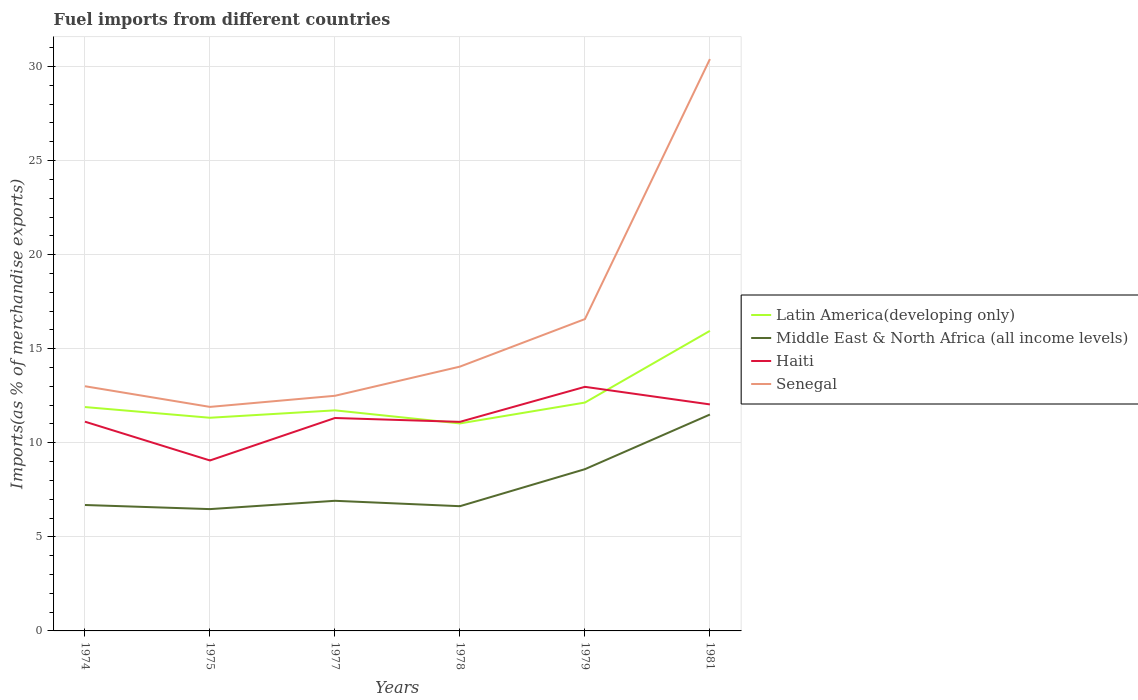Does the line corresponding to Middle East & North Africa (all income levels) intersect with the line corresponding to Senegal?
Make the answer very short. No. Is the number of lines equal to the number of legend labels?
Your response must be concise. Yes. Across all years, what is the maximum percentage of imports to different countries in Latin America(developing only)?
Offer a terse response. 11.03. In which year was the percentage of imports to different countries in Latin America(developing only) maximum?
Offer a terse response. 1978. What is the total percentage of imports to different countries in Senegal in the graph?
Offer a very short reply. -0.59. What is the difference between the highest and the second highest percentage of imports to different countries in Senegal?
Offer a very short reply. 18.49. What is the difference between the highest and the lowest percentage of imports to different countries in Middle East & North Africa (all income levels)?
Offer a very short reply. 2. How many lines are there?
Make the answer very short. 4. How many years are there in the graph?
Your answer should be very brief. 6. Are the values on the major ticks of Y-axis written in scientific E-notation?
Give a very brief answer. No. Does the graph contain any zero values?
Your answer should be very brief. No. Does the graph contain grids?
Your answer should be compact. Yes. Where does the legend appear in the graph?
Offer a terse response. Center right. How many legend labels are there?
Your response must be concise. 4. How are the legend labels stacked?
Give a very brief answer. Vertical. What is the title of the graph?
Provide a succinct answer. Fuel imports from different countries. Does "High income: OECD" appear as one of the legend labels in the graph?
Provide a succinct answer. No. What is the label or title of the X-axis?
Provide a short and direct response. Years. What is the label or title of the Y-axis?
Ensure brevity in your answer.  Imports(as % of merchandise exports). What is the Imports(as % of merchandise exports) of Latin America(developing only) in 1974?
Your response must be concise. 11.9. What is the Imports(as % of merchandise exports) in Middle East & North Africa (all income levels) in 1974?
Ensure brevity in your answer.  6.69. What is the Imports(as % of merchandise exports) of Haiti in 1974?
Your answer should be compact. 11.12. What is the Imports(as % of merchandise exports) of Senegal in 1974?
Give a very brief answer. 13.01. What is the Imports(as % of merchandise exports) of Latin America(developing only) in 1975?
Keep it short and to the point. 11.33. What is the Imports(as % of merchandise exports) of Middle East & North Africa (all income levels) in 1975?
Ensure brevity in your answer.  6.47. What is the Imports(as % of merchandise exports) in Haiti in 1975?
Your response must be concise. 9.06. What is the Imports(as % of merchandise exports) of Senegal in 1975?
Offer a terse response. 11.91. What is the Imports(as % of merchandise exports) in Latin America(developing only) in 1977?
Give a very brief answer. 11.72. What is the Imports(as % of merchandise exports) of Middle East & North Africa (all income levels) in 1977?
Offer a very short reply. 6.92. What is the Imports(as % of merchandise exports) of Haiti in 1977?
Give a very brief answer. 11.32. What is the Imports(as % of merchandise exports) of Senegal in 1977?
Provide a short and direct response. 12.5. What is the Imports(as % of merchandise exports) in Latin America(developing only) in 1978?
Make the answer very short. 11.03. What is the Imports(as % of merchandise exports) in Middle East & North Africa (all income levels) in 1978?
Your answer should be very brief. 6.63. What is the Imports(as % of merchandise exports) in Haiti in 1978?
Your response must be concise. 11.11. What is the Imports(as % of merchandise exports) of Senegal in 1978?
Your answer should be very brief. 14.05. What is the Imports(as % of merchandise exports) of Latin America(developing only) in 1979?
Offer a terse response. 12.14. What is the Imports(as % of merchandise exports) in Middle East & North Africa (all income levels) in 1979?
Make the answer very short. 8.6. What is the Imports(as % of merchandise exports) of Haiti in 1979?
Provide a short and direct response. 12.97. What is the Imports(as % of merchandise exports) in Senegal in 1979?
Your answer should be compact. 16.58. What is the Imports(as % of merchandise exports) in Latin America(developing only) in 1981?
Provide a short and direct response. 15.95. What is the Imports(as % of merchandise exports) in Middle East & North Africa (all income levels) in 1981?
Provide a succinct answer. 11.5. What is the Imports(as % of merchandise exports) of Haiti in 1981?
Your answer should be compact. 12.04. What is the Imports(as % of merchandise exports) of Senegal in 1981?
Give a very brief answer. 30.4. Across all years, what is the maximum Imports(as % of merchandise exports) of Latin America(developing only)?
Provide a short and direct response. 15.95. Across all years, what is the maximum Imports(as % of merchandise exports) in Middle East & North Africa (all income levels)?
Provide a short and direct response. 11.5. Across all years, what is the maximum Imports(as % of merchandise exports) of Haiti?
Make the answer very short. 12.97. Across all years, what is the maximum Imports(as % of merchandise exports) of Senegal?
Offer a terse response. 30.4. Across all years, what is the minimum Imports(as % of merchandise exports) in Latin America(developing only)?
Make the answer very short. 11.03. Across all years, what is the minimum Imports(as % of merchandise exports) of Middle East & North Africa (all income levels)?
Ensure brevity in your answer.  6.47. Across all years, what is the minimum Imports(as % of merchandise exports) in Haiti?
Provide a succinct answer. 9.06. Across all years, what is the minimum Imports(as % of merchandise exports) in Senegal?
Make the answer very short. 11.91. What is the total Imports(as % of merchandise exports) of Latin America(developing only) in the graph?
Your answer should be very brief. 74.07. What is the total Imports(as % of merchandise exports) of Middle East & North Africa (all income levels) in the graph?
Your response must be concise. 46.81. What is the total Imports(as % of merchandise exports) in Haiti in the graph?
Keep it short and to the point. 67.63. What is the total Imports(as % of merchandise exports) in Senegal in the graph?
Give a very brief answer. 98.43. What is the difference between the Imports(as % of merchandise exports) of Latin America(developing only) in 1974 and that in 1975?
Provide a short and direct response. 0.57. What is the difference between the Imports(as % of merchandise exports) of Middle East & North Africa (all income levels) in 1974 and that in 1975?
Offer a terse response. 0.22. What is the difference between the Imports(as % of merchandise exports) of Haiti in 1974 and that in 1975?
Offer a very short reply. 2.06. What is the difference between the Imports(as % of merchandise exports) in Senegal in 1974 and that in 1975?
Provide a succinct answer. 1.1. What is the difference between the Imports(as % of merchandise exports) in Latin America(developing only) in 1974 and that in 1977?
Your response must be concise. 0.18. What is the difference between the Imports(as % of merchandise exports) of Middle East & North Africa (all income levels) in 1974 and that in 1977?
Your answer should be very brief. -0.22. What is the difference between the Imports(as % of merchandise exports) of Haiti in 1974 and that in 1977?
Keep it short and to the point. -0.2. What is the difference between the Imports(as % of merchandise exports) in Senegal in 1974 and that in 1977?
Offer a terse response. 0.51. What is the difference between the Imports(as % of merchandise exports) of Latin America(developing only) in 1974 and that in 1978?
Provide a succinct answer. 0.87. What is the difference between the Imports(as % of merchandise exports) of Middle East & North Africa (all income levels) in 1974 and that in 1978?
Make the answer very short. 0.06. What is the difference between the Imports(as % of merchandise exports) of Haiti in 1974 and that in 1978?
Your answer should be very brief. 0.01. What is the difference between the Imports(as % of merchandise exports) in Senegal in 1974 and that in 1978?
Offer a very short reply. -1.04. What is the difference between the Imports(as % of merchandise exports) in Latin America(developing only) in 1974 and that in 1979?
Ensure brevity in your answer.  -0.24. What is the difference between the Imports(as % of merchandise exports) in Middle East & North Africa (all income levels) in 1974 and that in 1979?
Provide a short and direct response. -1.9. What is the difference between the Imports(as % of merchandise exports) in Haiti in 1974 and that in 1979?
Offer a very short reply. -1.85. What is the difference between the Imports(as % of merchandise exports) of Senegal in 1974 and that in 1979?
Provide a succinct answer. -3.57. What is the difference between the Imports(as % of merchandise exports) of Latin America(developing only) in 1974 and that in 1981?
Offer a terse response. -4.05. What is the difference between the Imports(as % of merchandise exports) of Middle East & North Africa (all income levels) in 1974 and that in 1981?
Ensure brevity in your answer.  -4.81. What is the difference between the Imports(as % of merchandise exports) of Haiti in 1974 and that in 1981?
Provide a succinct answer. -0.92. What is the difference between the Imports(as % of merchandise exports) of Senegal in 1974 and that in 1981?
Give a very brief answer. -17.39. What is the difference between the Imports(as % of merchandise exports) in Latin America(developing only) in 1975 and that in 1977?
Keep it short and to the point. -0.39. What is the difference between the Imports(as % of merchandise exports) of Middle East & North Africa (all income levels) in 1975 and that in 1977?
Offer a very short reply. -0.44. What is the difference between the Imports(as % of merchandise exports) in Haiti in 1975 and that in 1977?
Your response must be concise. -2.26. What is the difference between the Imports(as % of merchandise exports) in Senegal in 1975 and that in 1977?
Offer a terse response. -0.59. What is the difference between the Imports(as % of merchandise exports) in Latin America(developing only) in 1975 and that in 1978?
Offer a terse response. 0.3. What is the difference between the Imports(as % of merchandise exports) of Middle East & North Africa (all income levels) in 1975 and that in 1978?
Your answer should be very brief. -0.15. What is the difference between the Imports(as % of merchandise exports) of Haiti in 1975 and that in 1978?
Provide a succinct answer. -2.05. What is the difference between the Imports(as % of merchandise exports) of Senegal in 1975 and that in 1978?
Your response must be concise. -2.14. What is the difference between the Imports(as % of merchandise exports) in Latin America(developing only) in 1975 and that in 1979?
Offer a very short reply. -0.81. What is the difference between the Imports(as % of merchandise exports) in Middle East & North Africa (all income levels) in 1975 and that in 1979?
Your answer should be very brief. -2.12. What is the difference between the Imports(as % of merchandise exports) of Haiti in 1975 and that in 1979?
Provide a short and direct response. -3.91. What is the difference between the Imports(as % of merchandise exports) of Senegal in 1975 and that in 1979?
Provide a short and direct response. -4.67. What is the difference between the Imports(as % of merchandise exports) of Latin America(developing only) in 1975 and that in 1981?
Make the answer very short. -4.62. What is the difference between the Imports(as % of merchandise exports) of Middle East & North Africa (all income levels) in 1975 and that in 1981?
Offer a terse response. -5.03. What is the difference between the Imports(as % of merchandise exports) in Haiti in 1975 and that in 1981?
Offer a terse response. -2.98. What is the difference between the Imports(as % of merchandise exports) of Senegal in 1975 and that in 1981?
Your answer should be compact. -18.49. What is the difference between the Imports(as % of merchandise exports) of Latin America(developing only) in 1977 and that in 1978?
Keep it short and to the point. 0.69. What is the difference between the Imports(as % of merchandise exports) in Middle East & North Africa (all income levels) in 1977 and that in 1978?
Provide a succinct answer. 0.29. What is the difference between the Imports(as % of merchandise exports) in Haiti in 1977 and that in 1978?
Your response must be concise. 0.2. What is the difference between the Imports(as % of merchandise exports) in Senegal in 1977 and that in 1978?
Offer a very short reply. -1.55. What is the difference between the Imports(as % of merchandise exports) in Latin America(developing only) in 1977 and that in 1979?
Your response must be concise. -0.41. What is the difference between the Imports(as % of merchandise exports) in Middle East & North Africa (all income levels) in 1977 and that in 1979?
Your answer should be compact. -1.68. What is the difference between the Imports(as % of merchandise exports) of Haiti in 1977 and that in 1979?
Your response must be concise. -1.66. What is the difference between the Imports(as % of merchandise exports) in Senegal in 1977 and that in 1979?
Give a very brief answer. -4.08. What is the difference between the Imports(as % of merchandise exports) of Latin America(developing only) in 1977 and that in 1981?
Make the answer very short. -4.23. What is the difference between the Imports(as % of merchandise exports) in Middle East & North Africa (all income levels) in 1977 and that in 1981?
Your answer should be very brief. -4.59. What is the difference between the Imports(as % of merchandise exports) in Haiti in 1977 and that in 1981?
Provide a short and direct response. -0.72. What is the difference between the Imports(as % of merchandise exports) of Senegal in 1977 and that in 1981?
Offer a terse response. -17.9. What is the difference between the Imports(as % of merchandise exports) in Latin America(developing only) in 1978 and that in 1979?
Keep it short and to the point. -1.11. What is the difference between the Imports(as % of merchandise exports) in Middle East & North Africa (all income levels) in 1978 and that in 1979?
Your answer should be compact. -1.97. What is the difference between the Imports(as % of merchandise exports) in Haiti in 1978 and that in 1979?
Provide a short and direct response. -1.86. What is the difference between the Imports(as % of merchandise exports) in Senegal in 1978 and that in 1979?
Provide a short and direct response. -2.53. What is the difference between the Imports(as % of merchandise exports) in Latin America(developing only) in 1978 and that in 1981?
Your answer should be compact. -4.92. What is the difference between the Imports(as % of merchandise exports) in Middle East & North Africa (all income levels) in 1978 and that in 1981?
Your answer should be compact. -4.87. What is the difference between the Imports(as % of merchandise exports) in Haiti in 1978 and that in 1981?
Your response must be concise. -0.93. What is the difference between the Imports(as % of merchandise exports) of Senegal in 1978 and that in 1981?
Offer a very short reply. -16.35. What is the difference between the Imports(as % of merchandise exports) of Latin America(developing only) in 1979 and that in 1981?
Keep it short and to the point. -3.81. What is the difference between the Imports(as % of merchandise exports) of Middle East & North Africa (all income levels) in 1979 and that in 1981?
Your answer should be compact. -2.9. What is the difference between the Imports(as % of merchandise exports) in Haiti in 1979 and that in 1981?
Offer a very short reply. 0.93. What is the difference between the Imports(as % of merchandise exports) of Senegal in 1979 and that in 1981?
Make the answer very short. -13.82. What is the difference between the Imports(as % of merchandise exports) in Latin America(developing only) in 1974 and the Imports(as % of merchandise exports) in Middle East & North Africa (all income levels) in 1975?
Your response must be concise. 5.42. What is the difference between the Imports(as % of merchandise exports) of Latin America(developing only) in 1974 and the Imports(as % of merchandise exports) of Haiti in 1975?
Ensure brevity in your answer.  2.84. What is the difference between the Imports(as % of merchandise exports) in Latin America(developing only) in 1974 and the Imports(as % of merchandise exports) in Senegal in 1975?
Give a very brief answer. -0.01. What is the difference between the Imports(as % of merchandise exports) of Middle East & North Africa (all income levels) in 1974 and the Imports(as % of merchandise exports) of Haiti in 1975?
Make the answer very short. -2.37. What is the difference between the Imports(as % of merchandise exports) in Middle East & North Africa (all income levels) in 1974 and the Imports(as % of merchandise exports) in Senegal in 1975?
Offer a very short reply. -5.21. What is the difference between the Imports(as % of merchandise exports) in Haiti in 1974 and the Imports(as % of merchandise exports) in Senegal in 1975?
Provide a succinct answer. -0.79. What is the difference between the Imports(as % of merchandise exports) of Latin America(developing only) in 1974 and the Imports(as % of merchandise exports) of Middle East & North Africa (all income levels) in 1977?
Your answer should be very brief. 4.98. What is the difference between the Imports(as % of merchandise exports) in Latin America(developing only) in 1974 and the Imports(as % of merchandise exports) in Haiti in 1977?
Offer a terse response. 0.58. What is the difference between the Imports(as % of merchandise exports) in Latin America(developing only) in 1974 and the Imports(as % of merchandise exports) in Senegal in 1977?
Provide a short and direct response. -0.6. What is the difference between the Imports(as % of merchandise exports) in Middle East & North Africa (all income levels) in 1974 and the Imports(as % of merchandise exports) in Haiti in 1977?
Provide a succinct answer. -4.62. What is the difference between the Imports(as % of merchandise exports) of Middle East & North Africa (all income levels) in 1974 and the Imports(as % of merchandise exports) of Senegal in 1977?
Provide a short and direct response. -5.81. What is the difference between the Imports(as % of merchandise exports) of Haiti in 1974 and the Imports(as % of merchandise exports) of Senegal in 1977?
Your answer should be compact. -1.38. What is the difference between the Imports(as % of merchandise exports) in Latin America(developing only) in 1974 and the Imports(as % of merchandise exports) in Middle East & North Africa (all income levels) in 1978?
Ensure brevity in your answer.  5.27. What is the difference between the Imports(as % of merchandise exports) of Latin America(developing only) in 1974 and the Imports(as % of merchandise exports) of Haiti in 1978?
Keep it short and to the point. 0.79. What is the difference between the Imports(as % of merchandise exports) in Latin America(developing only) in 1974 and the Imports(as % of merchandise exports) in Senegal in 1978?
Your answer should be compact. -2.15. What is the difference between the Imports(as % of merchandise exports) in Middle East & North Africa (all income levels) in 1974 and the Imports(as % of merchandise exports) in Haiti in 1978?
Provide a succinct answer. -4.42. What is the difference between the Imports(as % of merchandise exports) of Middle East & North Africa (all income levels) in 1974 and the Imports(as % of merchandise exports) of Senegal in 1978?
Ensure brevity in your answer.  -7.36. What is the difference between the Imports(as % of merchandise exports) in Haiti in 1974 and the Imports(as % of merchandise exports) in Senegal in 1978?
Make the answer very short. -2.93. What is the difference between the Imports(as % of merchandise exports) of Latin America(developing only) in 1974 and the Imports(as % of merchandise exports) of Middle East & North Africa (all income levels) in 1979?
Provide a short and direct response. 3.3. What is the difference between the Imports(as % of merchandise exports) of Latin America(developing only) in 1974 and the Imports(as % of merchandise exports) of Haiti in 1979?
Offer a very short reply. -1.07. What is the difference between the Imports(as % of merchandise exports) in Latin America(developing only) in 1974 and the Imports(as % of merchandise exports) in Senegal in 1979?
Offer a very short reply. -4.68. What is the difference between the Imports(as % of merchandise exports) of Middle East & North Africa (all income levels) in 1974 and the Imports(as % of merchandise exports) of Haiti in 1979?
Offer a very short reply. -6.28. What is the difference between the Imports(as % of merchandise exports) in Middle East & North Africa (all income levels) in 1974 and the Imports(as % of merchandise exports) in Senegal in 1979?
Provide a succinct answer. -9.88. What is the difference between the Imports(as % of merchandise exports) of Haiti in 1974 and the Imports(as % of merchandise exports) of Senegal in 1979?
Ensure brevity in your answer.  -5.45. What is the difference between the Imports(as % of merchandise exports) of Latin America(developing only) in 1974 and the Imports(as % of merchandise exports) of Middle East & North Africa (all income levels) in 1981?
Your response must be concise. 0.4. What is the difference between the Imports(as % of merchandise exports) of Latin America(developing only) in 1974 and the Imports(as % of merchandise exports) of Haiti in 1981?
Give a very brief answer. -0.14. What is the difference between the Imports(as % of merchandise exports) in Latin America(developing only) in 1974 and the Imports(as % of merchandise exports) in Senegal in 1981?
Offer a very short reply. -18.5. What is the difference between the Imports(as % of merchandise exports) of Middle East & North Africa (all income levels) in 1974 and the Imports(as % of merchandise exports) of Haiti in 1981?
Your answer should be very brief. -5.35. What is the difference between the Imports(as % of merchandise exports) of Middle East & North Africa (all income levels) in 1974 and the Imports(as % of merchandise exports) of Senegal in 1981?
Offer a terse response. -23.7. What is the difference between the Imports(as % of merchandise exports) of Haiti in 1974 and the Imports(as % of merchandise exports) of Senegal in 1981?
Offer a very short reply. -19.27. What is the difference between the Imports(as % of merchandise exports) of Latin America(developing only) in 1975 and the Imports(as % of merchandise exports) of Middle East & North Africa (all income levels) in 1977?
Keep it short and to the point. 4.41. What is the difference between the Imports(as % of merchandise exports) in Latin America(developing only) in 1975 and the Imports(as % of merchandise exports) in Haiti in 1977?
Make the answer very short. 0.01. What is the difference between the Imports(as % of merchandise exports) in Latin America(developing only) in 1975 and the Imports(as % of merchandise exports) in Senegal in 1977?
Your answer should be compact. -1.17. What is the difference between the Imports(as % of merchandise exports) in Middle East & North Africa (all income levels) in 1975 and the Imports(as % of merchandise exports) in Haiti in 1977?
Provide a succinct answer. -4.84. What is the difference between the Imports(as % of merchandise exports) of Middle East & North Africa (all income levels) in 1975 and the Imports(as % of merchandise exports) of Senegal in 1977?
Keep it short and to the point. -6.02. What is the difference between the Imports(as % of merchandise exports) of Haiti in 1975 and the Imports(as % of merchandise exports) of Senegal in 1977?
Provide a succinct answer. -3.44. What is the difference between the Imports(as % of merchandise exports) of Latin America(developing only) in 1975 and the Imports(as % of merchandise exports) of Middle East & North Africa (all income levels) in 1978?
Make the answer very short. 4.7. What is the difference between the Imports(as % of merchandise exports) of Latin America(developing only) in 1975 and the Imports(as % of merchandise exports) of Haiti in 1978?
Provide a succinct answer. 0.22. What is the difference between the Imports(as % of merchandise exports) in Latin America(developing only) in 1975 and the Imports(as % of merchandise exports) in Senegal in 1978?
Ensure brevity in your answer.  -2.72. What is the difference between the Imports(as % of merchandise exports) of Middle East & North Africa (all income levels) in 1975 and the Imports(as % of merchandise exports) of Haiti in 1978?
Offer a very short reply. -4.64. What is the difference between the Imports(as % of merchandise exports) of Middle East & North Africa (all income levels) in 1975 and the Imports(as % of merchandise exports) of Senegal in 1978?
Offer a very short reply. -7.57. What is the difference between the Imports(as % of merchandise exports) of Haiti in 1975 and the Imports(as % of merchandise exports) of Senegal in 1978?
Make the answer very short. -4.99. What is the difference between the Imports(as % of merchandise exports) of Latin America(developing only) in 1975 and the Imports(as % of merchandise exports) of Middle East & North Africa (all income levels) in 1979?
Your answer should be compact. 2.73. What is the difference between the Imports(as % of merchandise exports) of Latin America(developing only) in 1975 and the Imports(as % of merchandise exports) of Haiti in 1979?
Give a very brief answer. -1.64. What is the difference between the Imports(as % of merchandise exports) in Latin America(developing only) in 1975 and the Imports(as % of merchandise exports) in Senegal in 1979?
Your response must be concise. -5.24. What is the difference between the Imports(as % of merchandise exports) of Middle East & North Africa (all income levels) in 1975 and the Imports(as % of merchandise exports) of Haiti in 1979?
Offer a very short reply. -6.5. What is the difference between the Imports(as % of merchandise exports) in Middle East & North Africa (all income levels) in 1975 and the Imports(as % of merchandise exports) in Senegal in 1979?
Offer a terse response. -10.1. What is the difference between the Imports(as % of merchandise exports) in Haiti in 1975 and the Imports(as % of merchandise exports) in Senegal in 1979?
Your answer should be very brief. -7.52. What is the difference between the Imports(as % of merchandise exports) in Latin America(developing only) in 1975 and the Imports(as % of merchandise exports) in Middle East & North Africa (all income levels) in 1981?
Your answer should be compact. -0.17. What is the difference between the Imports(as % of merchandise exports) of Latin America(developing only) in 1975 and the Imports(as % of merchandise exports) of Haiti in 1981?
Your answer should be very brief. -0.71. What is the difference between the Imports(as % of merchandise exports) of Latin America(developing only) in 1975 and the Imports(as % of merchandise exports) of Senegal in 1981?
Your response must be concise. -19.07. What is the difference between the Imports(as % of merchandise exports) of Middle East & North Africa (all income levels) in 1975 and the Imports(as % of merchandise exports) of Haiti in 1981?
Make the answer very short. -5.57. What is the difference between the Imports(as % of merchandise exports) of Middle East & North Africa (all income levels) in 1975 and the Imports(as % of merchandise exports) of Senegal in 1981?
Keep it short and to the point. -23.92. What is the difference between the Imports(as % of merchandise exports) of Haiti in 1975 and the Imports(as % of merchandise exports) of Senegal in 1981?
Provide a short and direct response. -21.34. What is the difference between the Imports(as % of merchandise exports) of Latin America(developing only) in 1977 and the Imports(as % of merchandise exports) of Middle East & North Africa (all income levels) in 1978?
Provide a succinct answer. 5.09. What is the difference between the Imports(as % of merchandise exports) of Latin America(developing only) in 1977 and the Imports(as % of merchandise exports) of Haiti in 1978?
Give a very brief answer. 0.61. What is the difference between the Imports(as % of merchandise exports) of Latin America(developing only) in 1977 and the Imports(as % of merchandise exports) of Senegal in 1978?
Ensure brevity in your answer.  -2.33. What is the difference between the Imports(as % of merchandise exports) of Middle East & North Africa (all income levels) in 1977 and the Imports(as % of merchandise exports) of Haiti in 1978?
Offer a terse response. -4.2. What is the difference between the Imports(as % of merchandise exports) of Middle East & North Africa (all income levels) in 1977 and the Imports(as % of merchandise exports) of Senegal in 1978?
Provide a short and direct response. -7.13. What is the difference between the Imports(as % of merchandise exports) in Haiti in 1977 and the Imports(as % of merchandise exports) in Senegal in 1978?
Offer a very short reply. -2.73. What is the difference between the Imports(as % of merchandise exports) of Latin America(developing only) in 1977 and the Imports(as % of merchandise exports) of Middle East & North Africa (all income levels) in 1979?
Offer a terse response. 3.13. What is the difference between the Imports(as % of merchandise exports) in Latin America(developing only) in 1977 and the Imports(as % of merchandise exports) in Haiti in 1979?
Make the answer very short. -1.25. What is the difference between the Imports(as % of merchandise exports) in Latin America(developing only) in 1977 and the Imports(as % of merchandise exports) in Senegal in 1979?
Keep it short and to the point. -4.85. What is the difference between the Imports(as % of merchandise exports) in Middle East & North Africa (all income levels) in 1977 and the Imports(as % of merchandise exports) in Haiti in 1979?
Offer a terse response. -6.06. What is the difference between the Imports(as % of merchandise exports) in Middle East & North Africa (all income levels) in 1977 and the Imports(as % of merchandise exports) in Senegal in 1979?
Make the answer very short. -9.66. What is the difference between the Imports(as % of merchandise exports) of Haiti in 1977 and the Imports(as % of merchandise exports) of Senegal in 1979?
Provide a succinct answer. -5.26. What is the difference between the Imports(as % of merchandise exports) of Latin America(developing only) in 1977 and the Imports(as % of merchandise exports) of Middle East & North Africa (all income levels) in 1981?
Provide a succinct answer. 0.22. What is the difference between the Imports(as % of merchandise exports) in Latin America(developing only) in 1977 and the Imports(as % of merchandise exports) in Haiti in 1981?
Your answer should be very brief. -0.32. What is the difference between the Imports(as % of merchandise exports) of Latin America(developing only) in 1977 and the Imports(as % of merchandise exports) of Senegal in 1981?
Ensure brevity in your answer.  -18.67. What is the difference between the Imports(as % of merchandise exports) in Middle East & North Africa (all income levels) in 1977 and the Imports(as % of merchandise exports) in Haiti in 1981?
Provide a succinct answer. -5.12. What is the difference between the Imports(as % of merchandise exports) in Middle East & North Africa (all income levels) in 1977 and the Imports(as % of merchandise exports) in Senegal in 1981?
Your answer should be very brief. -23.48. What is the difference between the Imports(as % of merchandise exports) of Haiti in 1977 and the Imports(as % of merchandise exports) of Senegal in 1981?
Provide a short and direct response. -19.08. What is the difference between the Imports(as % of merchandise exports) in Latin America(developing only) in 1978 and the Imports(as % of merchandise exports) in Middle East & North Africa (all income levels) in 1979?
Provide a succinct answer. 2.43. What is the difference between the Imports(as % of merchandise exports) of Latin America(developing only) in 1978 and the Imports(as % of merchandise exports) of Haiti in 1979?
Make the answer very short. -1.95. What is the difference between the Imports(as % of merchandise exports) in Latin America(developing only) in 1978 and the Imports(as % of merchandise exports) in Senegal in 1979?
Ensure brevity in your answer.  -5.55. What is the difference between the Imports(as % of merchandise exports) in Middle East & North Africa (all income levels) in 1978 and the Imports(as % of merchandise exports) in Haiti in 1979?
Provide a succinct answer. -6.34. What is the difference between the Imports(as % of merchandise exports) of Middle East & North Africa (all income levels) in 1978 and the Imports(as % of merchandise exports) of Senegal in 1979?
Your answer should be compact. -9.95. What is the difference between the Imports(as % of merchandise exports) in Haiti in 1978 and the Imports(as % of merchandise exports) in Senegal in 1979?
Offer a terse response. -5.46. What is the difference between the Imports(as % of merchandise exports) of Latin America(developing only) in 1978 and the Imports(as % of merchandise exports) of Middle East & North Africa (all income levels) in 1981?
Make the answer very short. -0.47. What is the difference between the Imports(as % of merchandise exports) of Latin America(developing only) in 1978 and the Imports(as % of merchandise exports) of Haiti in 1981?
Keep it short and to the point. -1.01. What is the difference between the Imports(as % of merchandise exports) in Latin America(developing only) in 1978 and the Imports(as % of merchandise exports) in Senegal in 1981?
Keep it short and to the point. -19.37. What is the difference between the Imports(as % of merchandise exports) of Middle East & North Africa (all income levels) in 1978 and the Imports(as % of merchandise exports) of Haiti in 1981?
Your answer should be compact. -5.41. What is the difference between the Imports(as % of merchandise exports) of Middle East & North Africa (all income levels) in 1978 and the Imports(as % of merchandise exports) of Senegal in 1981?
Your response must be concise. -23.77. What is the difference between the Imports(as % of merchandise exports) of Haiti in 1978 and the Imports(as % of merchandise exports) of Senegal in 1981?
Your response must be concise. -19.28. What is the difference between the Imports(as % of merchandise exports) of Latin America(developing only) in 1979 and the Imports(as % of merchandise exports) of Middle East & North Africa (all income levels) in 1981?
Provide a succinct answer. 0.64. What is the difference between the Imports(as % of merchandise exports) of Latin America(developing only) in 1979 and the Imports(as % of merchandise exports) of Haiti in 1981?
Provide a short and direct response. 0.1. What is the difference between the Imports(as % of merchandise exports) in Latin America(developing only) in 1979 and the Imports(as % of merchandise exports) in Senegal in 1981?
Give a very brief answer. -18.26. What is the difference between the Imports(as % of merchandise exports) of Middle East & North Africa (all income levels) in 1979 and the Imports(as % of merchandise exports) of Haiti in 1981?
Provide a short and direct response. -3.44. What is the difference between the Imports(as % of merchandise exports) in Middle East & North Africa (all income levels) in 1979 and the Imports(as % of merchandise exports) in Senegal in 1981?
Provide a succinct answer. -21.8. What is the difference between the Imports(as % of merchandise exports) in Haiti in 1979 and the Imports(as % of merchandise exports) in Senegal in 1981?
Your answer should be very brief. -17.42. What is the average Imports(as % of merchandise exports) of Latin America(developing only) per year?
Make the answer very short. 12.35. What is the average Imports(as % of merchandise exports) in Middle East & North Africa (all income levels) per year?
Make the answer very short. 7.8. What is the average Imports(as % of merchandise exports) in Haiti per year?
Provide a short and direct response. 11.27. What is the average Imports(as % of merchandise exports) of Senegal per year?
Provide a succinct answer. 16.41. In the year 1974, what is the difference between the Imports(as % of merchandise exports) in Latin America(developing only) and Imports(as % of merchandise exports) in Middle East & North Africa (all income levels)?
Make the answer very short. 5.21. In the year 1974, what is the difference between the Imports(as % of merchandise exports) in Latin America(developing only) and Imports(as % of merchandise exports) in Haiti?
Ensure brevity in your answer.  0.78. In the year 1974, what is the difference between the Imports(as % of merchandise exports) in Latin America(developing only) and Imports(as % of merchandise exports) in Senegal?
Keep it short and to the point. -1.11. In the year 1974, what is the difference between the Imports(as % of merchandise exports) in Middle East & North Africa (all income levels) and Imports(as % of merchandise exports) in Haiti?
Your response must be concise. -4.43. In the year 1974, what is the difference between the Imports(as % of merchandise exports) in Middle East & North Africa (all income levels) and Imports(as % of merchandise exports) in Senegal?
Your answer should be compact. -6.31. In the year 1974, what is the difference between the Imports(as % of merchandise exports) in Haiti and Imports(as % of merchandise exports) in Senegal?
Keep it short and to the point. -1.88. In the year 1975, what is the difference between the Imports(as % of merchandise exports) of Latin America(developing only) and Imports(as % of merchandise exports) of Middle East & North Africa (all income levels)?
Offer a terse response. 4.86. In the year 1975, what is the difference between the Imports(as % of merchandise exports) in Latin America(developing only) and Imports(as % of merchandise exports) in Haiti?
Provide a short and direct response. 2.27. In the year 1975, what is the difference between the Imports(as % of merchandise exports) in Latin America(developing only) and Imports(as % of merchandise exports) in Senegal?
Offer a terse response. -0.58. In the year 1975, what is the difference between the Imports(as % of merchandise exports) of Middle East & North Africa (all income levels) and Imports(as % of merchandise exports) of Haiti?
Ensure brevity in your answer.  -2.59. In the year 1975, what is the difference between the Imports(as % of merchandise exports) in Middle East & North Africa (all income levels) and Imports(as % of merchandise exports) in Senegal?
Ensure brevity in your answer.  -5.43. In the year 1975, what is the difference between the Imports(as % of merchandise exports) in Haiti and Imports(as % of merchandise exports) in Senegal?
Offer a very short reply. -2.85. In the year 1977, what is the difference between the Imports(as % of merchandise exports) of Latin America(developing only) and Imports(as % of merchandise exports) of Middle East & North Africa (all income levels)?
Provide a succinct answer. 4.81. In the year 1977, what is the difference between the Imports(as % of merchandise exports) in Latin America(developing only) and Imports(as % of merchandise exports) in Haiti?
Offer a terse response. 0.41. In the year 1977, what is the difference between the Imports(as % of merchandise exports) in Latin America(developing only) and Imports(as % of merchandise exports) in Senegal?
Provide a succinct answer. -0.77. In the year 1977, what is the difference between the Imports(as % of merchandise exports) of Middle East & North Africa (all income levels) and Imports(as % of merchandise exports) of Haiti?
Provide a succinct answer. -4.4. In the year 1977, what is the difference between the Imports(as % of merchandise exports) in Middle East & North Africa (all income levels) and Imports(as % of merchandise exports) in Senegal?
Your response must be concise. -5.58. In the year 1977, what is the difference between the Imports(as % of merchandise exports) in Haiti and Imports(as % of merchandise exports) in Senegal?
Provide a succinct answer. -1.18. In the year 1978, what is the difference between the Imports(as % of merchandise exports) of Latin America(developing only) and Imports(as % of merchandise exports) of Middle East & North Africa (all income levels)?
Make the answer very short. 4.4. In the year 1978, what is the difference between the Imports(as % of merchandise exports) in Latin America(developing only) and Imports(as % of merchandise exports) in Haiti?
Offer a terse response. -0.08. In the year 1978, what is the difference between the Imports(as % of merchandise exports) of Latin America(developing only) and Imports(as % of merchandise exports) of Senegal?
Provide a short and direct response. -3.02. In the year 1978, what is the difference between the Imports(as % of merchandise exports) in Middle East & North Africa (all income levels) and Imports(as % of merchandise exports) in Haiti?
Provide a succinct answer. -4.48. In the year 1978, what is the difference between the Imports(as % of merchandise exports) of Middle East & North Africa (all income levels) and Imports(as % of merchandise exports) of Senegal?
Your answer should be very brief. -7.42. In the year 1978, what is the difference between the Imports(as % of merchandise exports) in Haiti and Imports(as % of merchandise exports) in Senegal?
Provide a succinct answer. -2.94. In the year 1979, what is the difference between the Imports(as % of merchandise exports) in Latin America(developing only) and Imports(as % of merchandise exports) in Middle East & North Africa (all income levels)?
Make the answer very short. 3.54. In the year 1979, what is the difference between the Imports(as % of merchandise exports) in Latin America(developing only) and Imports(as % of merchandise exports) in Haiti?
Ensure brevity in your answer.  -0.84. In the year 1979, what is the difference between the Imports(as % of merchandise exports) in Latin America(developing only) and Imports(as % of merchandise exports) in Senegal?
Ensure brevity in your answer.  -4.44. In the year 1979, what is the difference between the Imports(as % of merchandise exports) in Middle East & North Africa (all income levels) and Imports(as % of merchandise exports) in Haiti?
Your answer should be very brief. -4.38. In the year 1979, what is the difference between the Imports(as % of merchandise exports) in Middle East & North Africa (all income levels) and Imports(as % of merchandise exports) in Senegal?
Your response must be concise. -7.98. In the year 1979, what is the difference between the Imports(as % of merchandise exports) in Haiti and Imports(as % of merchandise exports) in Senegal?
Your response must be concise. -3.6. In the year 1981, what is the difference between the Imports(as % of merchandise exports) of Latin America(developing only) and Imports(as % of merchandise exports) of Middle East & North Africa (all income levels)?
Your answer should be compact. 4.45. In the year 1981, what is the difference between the Imports(as % of merchandise exports) of Latin America(developing only) and Imports(as % of merchandise exports) of Haiti?
Ensure brevity in your answer.  3.91. In the year 1981, what is the difference between the Imports(as % of merchandise exports) of Latin America(developing only) and Imports(as % of merchandise exports) of Senegal?
Offer a very short reply. -14.45. In the year 1981, what is the difference between the Imports(as % of merchandise exports) of Middle East & North Africa (all income levels) and Imports(as % of merchandise exports) of Haiti?
Keep it short and to the point. -0.54. In the year 1981, what is the difference between the Imports(as % of merchandise exports) of Middle East & North Africa (all income levels) and Imports(as % of merchandise exports) of Senegal?
Make the answer very short. -18.89. In the year 1981, what is the difference between the Imports(as % of merchandise exports) in Haiti and Imports(as % of merchandise exports) in Senegal?
Give a very brief answer. -18.36. What is the ratio of the Imports(as % of merchandise exports) of Latin America(developing only) in 1974 to that in 1975?
Your answer should be very brief. 1.05. What is the ratio of the Imports(as % of merchandise exports) in Middle East & North Africa (all income levels) in 1974 to that in 1975?
Make the answer very short. 1.03. What is the ratio of the Imports(as % of merchandise exports) of Haiti in 1974 to that in 1975?
Your response must be concise. 1.23. What is the ratio of the Imports(as % of merchandise exports) in Senegal in 1974 to that in 1975?
Offer a terse response. 1.09. What is the ratio of the Imports(as % of merchandise exports) in Latin America(developing only) in 1974 to that in 1977?
Make the answer very short. 1.01. What is the ratio of the Imports(as % of merchandise exports) of Haiti in 1974 to that in 1977?
Provide a short and direct response. 0.98. What is the ratio of the Imports(as % of merchandise exports) of Senegal in 1974 to that in 1977?
Give a very brief answer. 1.04. What is the ratio of the Imports(as % of merchandise exports) of Latin America(developing only) in 1974 to that in 1978?
Offer a terse response. 1.08. What is the ratio of the Imports(as % of merchandise exports) of Middle East & North Africa (all income levels) in 1974 to that in 1978?
Your answer should be very brief. 1.01. What is the ratio of the Imports(as % of merchandise exports) of Senegal in 1974 to that in 1978?
Your response must be concise. 0.93. What is the ratio of the Imports(as % of merchandise exports) of Latin America(developing only) in 1974 to that in 1979?
Your answer should be compact. 0.98. What is the ratio of the Imports(as % of merchandise exports) in Middle East & North Africa (all income levels) in 1974 to that in 1979?
Ensure brevity in your answer.  0.78. What is the ratio of the Imports(as % of merchandise exports) of Haiti in 1974 to that in 1979?
Ensure brevity in your answer.  0.86. What is the ratio of the Imports(as % of merchandise exports) in Senegal in 1974 to that in 1979?
Make the answer very short. 0.78. What is the ratio of the Imports(as % of merchandise exports) in Latin America(developing only) in 1974 to that in 1981?
Keep it short and to the point. 0.75. What is the ratio of the Imports(as % of merchandise exports) of Middle East & North Africa (all income levels) in 1974 to that in 1981?
Make the answer very short. 0.58. What is the ratio of the Imports(as % of merchandise exports) of Haiti in 1974 to that in 1981?
Provide a short and direct response. 0.92. What is the ratio of the Imports(as % of merchandise exports) of Senegal in 1974 to that in 1981?
Keep it short and to the point. 0.43. What is the ratio of the Imports(as % of merchandise exports) in Latin America(developing only) in 1975 to that in 1977?
Offer a terse response. 0.97. What is the ratio of the Imports(as % of merchandise exports) of Middle East & North Africa (all income levels) in 1975 to that in 1977?
Your answer should be compact. 0.94. What is the ratio of the Imports(as % of merchandise exports) of Haiti in 1975 to that in 1977?
Your response must be concise. 0.8. What is the ratio of the Imports(as % of merchandise exports) in Senegal in 1975 to that in 1977?
Provide a succinct answer. 0.95. What is the ratio of the Imports(as % of merchandise exports) of Latin America(developing only) in 1975 to that in 1978?
Provide a succinct answer. 1.03. What is the ratio of the Imports(as % of merchandise exports) of Middle East & North Africa (all income levels) in 1975 to that in 1978?
Make the answer very short. 0.98. What is the ratio of the Imports(as % of merchandise exports) of Haiti in 1975 to that in 1978?
Your answer should be very brief. 0.82. What is the ratio of the Imports(as % of merchandise exports) in Senegal in 1975 to that in 1978?
Your response must be concise. 0.85. What is the ratio of the Imports(as % of merchandise exports) in Latin America(developing only) in 1975 to that in 1979?
Offer a terse response. 0.93. What is the ratio of the Imports(as % of merchandise exports) in Middle East & North Africa (all income levels) in 1975 to that in 1979?
Make the answer very short. 0.75. What is the ratio of the Imports(as % of merchandise exports) of Haiti in 1975 to that in 1979?
Offer a very short reply. 0.7. What is the ratio of the Imports(as % of merchandise exports) of Senegal in 1975 to that in 1979?
Give a very brief answer. 0.72. What is the ratio of the Imports(as % of merchandise exports) of Latin America(developing only) in 1975 to that in 1981?
Offer a very short reply. 0.71. What is the ratio of the Imports(as % of merchandise exports) in Middle East & North Africa (all income levels) in 1975 to that in 1981?
Offer a very short reply. 0.56. What is the ratio of the Imports(as % of merchandise exports) of Haiti in 1975 to that in 1981?
Your answer should be very brief. 0.75. What is the ratio of the Imports(as % of merchandise exports) of Senegal in 1975 to that in 1981?
Give a very brief answer. 0.39. What is the ratio of the Imports(as % of merchandise exports) of Latin America(developing only) in 1977 to that in 1978?
Make the answer very short. 1.06. What is the ratio of the Imports(as % of merchandise exports) of Middle East & North Africa (all income levels) in 1977 to that in 1978?
Give a very brief answer. 1.04. What is the ratio of the Imports(as % of merchandise exports) in Haiti in 1977 to that in 1978?
Ensure brevity in your answer.  1.02. What is the ratio of the Imports(as % of merchandise exports) of Senegal in 1977 to that in 1978?
Your answer should be very brief. 0.89. What is the ratio of the Imports(as % of merchandise exports) in Latin America(developing only) in 1977 to that in 1979?
Offer a very short reply. 0.97. What is the ratio of the Imports(as % of merchandise exports) of Middle East & North Africa (all income levels) in 1977 to that in 1979?
Offer a very short reply. 0.8. What is the ratio of the Imports(as % of merchandise exports) of Haiti in 1977 to that in 1979?
Your answer should be compact. 0.87. What is the ratio of the Imports(as % of merchandise exports) in Senegal in 1977 to that in 1979?
Your answer should be very brief. 0.75. What is the ratio of the Imports(as % of merchandise exports) in Latin America(developing only) in 1977 to that in 1981?
Provide a succinct answer. 0.74. What is the ratio of the Imports(as % of merchandise exports) in Middle East & North Africa (all income levels) in 1977 to that in 1981?
Your response must be concise. 0.6. What is the ratio of the Imports(as % of merchandise exports) in Senegal in 1977 to that in 1981?
Your response must be concise. 0.41. What is the ratio of the Imports(as % of merchandise exports) in Latin America(developing only) in 1978 to that in 1979?
Your answer should be very brief. 0.91. What is the ratio of the Imports(as % of merchandise exports) of Middle East & North Africa (all income levels) in 1978 to that in 1979?
Offer a terse response. 0.77. What is the ratio of the Imports(as % of merchandise exports) in Haiti in 1978 to that in 1979?
Keep it short and to the point. 0.86. What is the ratio of the Imports(as % of merchandise exports) of Senegal in 1978 to that in 1979?
Make the answer very short. 0.85. What is the ratio of the Imports(as % of merchandise exports) in Latin America(developing only) in 1978 to that in 1981?
Provide a succinct answer. 0.69. What is the ratio of the Imports(as % of merchandise exports) in Middle East & North Africa (all income levels) in 1978 to that in 1981?
Offer a very short reply. 0.58. What is the ratio of the Imports(as % of merchandise exports) of Haiti in 1978 to that in 1981?
Your answer should be compact. 0.92. What is the ratio of the Imports(as % of merchandise exports) in Senegal in 1978 to that in 1981?
Your response must be concise. 0.46. What is the ratio of the Imports(as % of merchandise exports) of Latin America(developing only) in 1979 to that in 1981?
Provide a succinct answer. 0.76. What is the ratio of the Imports(as % of merchandise exports) of Middle East & North Africa (all income levels) in 1979 to that in 1981?
Your answer should be very brief. 0.75. What is the ratio of the Imports(as % of merchandise exports) of Haiti in 1979 to that in 1981?
Make the answer very short. 1.08. What is the ratio of the Imports(as % of merchandise exports) in Senegal in 1979 to that in 1981?
Provide a succinct answer. 0.55. What is the difference between the highest and the second highest Imports(as % of merchandise exports) of Latin America(developing only)?
Offer a terse response. 3.81. What is the difference between the highest and the second highest Imports(as % of merchandise exports) of Middle East & North Africa (all income levels)?
Ensure brevity in your answer.  2.9. What is the difference between the highest and the second highest Imports(as % of merchandise exports) of Haiti?
Offer a terse response. 0.93. What is the difference between the highest and the second highest Imports(as % of merchandise exports) in Senegal?
Provide a succinct answer. 13.82. What is the difference between the highest and the lowest Imports(as % of merchandise exports) in Latin America(developing only)?
Provide a succinct answer. 4.92. What is the difference between the highest and the lowest Imports(as % of merchandise exports) in Middle East & North Africa (all income levels)?
Your response must be concise. 5.03. What is the difference between the highest and the lowest Imports(as % of merchandise exports) in Haiti?
Give a very brief answer. 3.91. What is the difference between the highest and the lowest Imports(as % of merchandise exports) in Senegal?
Offer a terse response. 18.49. 